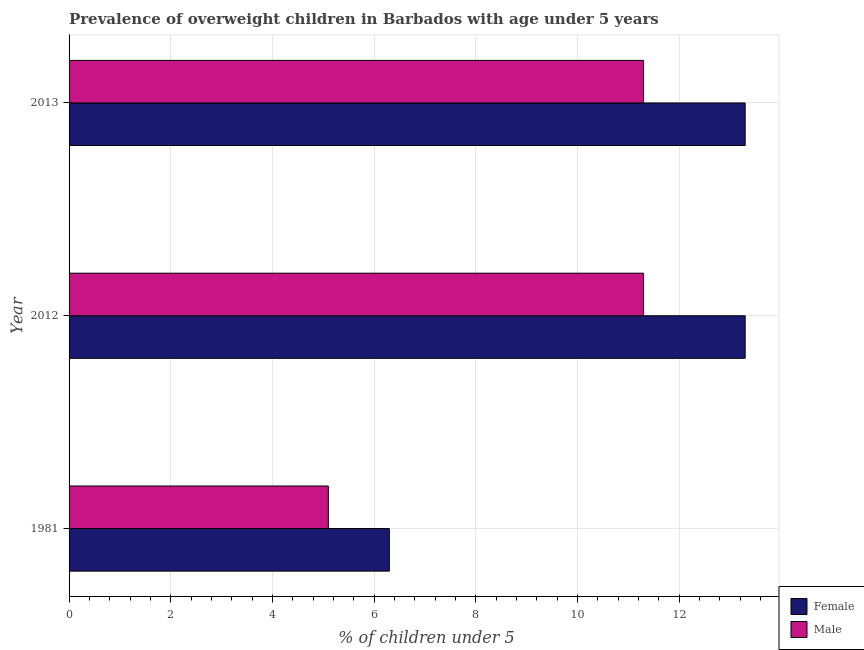How many different coloured bars are there?
Provide a succinct answer. 2. How many bars are there on the 3rd tick from the top?
Provide a short and direct response. 2. What is the label of the 1st group of bars from the top?
Ensure brevity in your answer.  2013. In how many cases, is the number of bars for a given year not equal to the number of legend labels?
Ensure brevity in your answer.  0. Across all years, what is the maximum percentage of obese male children?
Provide a succinct answer. 11.3. Across all years, what is the minimum percentage of obese male children?
Provide a short and direct response. 5.1. In which year was the percentage of obese female children maximum?
Your answer should be very brief. 2012. In which year was the percentage of obese male children minimum?
Offer a terse response. 1981. What is the total percentage of obese male children in the graph?
Give a very brief answer. 27.7. What is the difference between the percentage of obese female children in 1981 and that in 2013?
Keep it short and to the point. -7. What is the difference between the percentage of obese male children in 1981 and the percentage of obese female children in 2012?
Provide a succinct answer. -8.2. What is the average percentage of obese male children per year?
Offer a terse response. 9.23. What is the ratio of the percentage of obese female children in 1981 to that in 2012?
Keep it short and to the point. 0.47. Is the difference between the percentage of obese male children in 2012 and 2013 greater than the difference between the percentage of obese female children in 2012 and 2013?
Ensure brevity in your answer.  No. What is the difference between the highest and the second highest percentage of obese male children?
Provide a short and direct response. 0. Is the sum of the percentage of obese female children in 1981 and 2013 greater than the maximum percentage of obese male children across all years?
Your response must be concise. Yes. What does the 2nd bar from the top in 2013 represents?
Provide a short and direct response. Female. How many bars are there?
Make the answer very short. 6. Does the graph contain grids?
Your answer should be very brief. Yes. How are the legend labels stacked?
Your answer should be compact. Vertical. What is the title of the graph?
Make the answer very short. Prevalence of overweight children in Barbados with age under 5 years. Does "Malaria" appear as one of the legend labels in the graph?
Provide a succinct answer. No. What is the label or title of the X-axis?
Your response must be concise.  % of children under 5. What is the  % of children under 5 in Female in 1981?
Give a very brief answer. 6.3. What is the  % of children under 5 of Male in 1981?
Provide a succinct answer. 5.1. What is the  % of children under 5 of Female in 2012?
Your answer should be compact. 13.3. What is the  % of children under 5 in Male in 2012?
Provide a short and direct response. 11.3. What is the  % of children under 5 in Female in 2013?
Ensure brevity in your answer.  13.3. What is the  % of children under 5 of Male in 2013?
Offer a terse response. 11.3. Across all years, what is the maximum  % of children under 5 in Female?
Your answer should be compact. 13.3. Across all years, what is the maximum  % of children under 5 of Male?
Keep it short and to the point. 11.3. Across all years, what is the minimum  % of children under 5 in Female?
Your answer should be very brief. 6.3. Across all years, what is the minimum  % of children under 5 in Male?
Your answer should be very brief. 5.1. What is the total  % of children under 5 of Female in the graph?
Offer a terse response. 32.9. What is the total  % of children under 5 in Male in the graph?
Provide a short and direct response. 27.7. What is the difference between the  % of children under 5 of Female in 1981 and that in 2012?
Provide a succinct answer. -7. What is the difference between the  % of children under 5 of Male in 2012 and that in 2013?
Keep it short and to the point. 0. What is the difference between the  % of children under 5 of Female in 1981 and the  % of children under 5 of Male in 2012?
Provide a short and direct response. -5. What is the difference between the  % of children under 5 in Female in 1981 and the  % of children under 5 in Male in 2013?
Keep it short and to the point. -5. What is the average  % of children under 5 in Female per year?
Provide a succinct answer. 10.97. What is the average  % of children under 5 of Male per year?
Give a very brief answer. 9.23. In the year 1981, what is the difference between the  % of children under 5 of Female and  % of children under 5 of Male?
Offer a very short reply. 1.2. What is the ratio of the  % of children under 5 of Female in 1981 to that in 2012?
Ensure brevity in your answer.  0.47. What is the ratio of the  % of children under 5 of Male in 1981 to that in 2012?
Give a very brief answer. 0.45. What is the ratio of the  % of children under 5 of Female in 1981 to that in 2013?
Provide a succinct answer. 0.47. What is the ratio of the  % of children under 5 of Male in 1981 to that in 2013?
Ensure brevity in your answer.  0.45. What is the ratio of the  % of children under 5 in Female in 2012 to that in 2013?
Keep it short and to the point. 1. What is the difference between the highest and the second highest  % of children under 5 of Female?
Provide a succinct answer. 0. What is the difference between the highest and the second highest  % of children under 5 in Male?
Your answer should be very brief. 0. What is the difference between the highest and the lowest  % of children under 5 of Female?
Provide a short and direct response. 7. What is the difference between the highest and the lowest  % of children under 5 in Male?
Your answer should be compact. 6.2. 